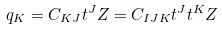Convert formula to latex. <formula><loc_0><loc_0><loc_500><loc_500>q _ { K } = C _ { K J } t ^ { J } Z = C _ { I J K } t ^ { J } t ^ { K } Z</formula> 